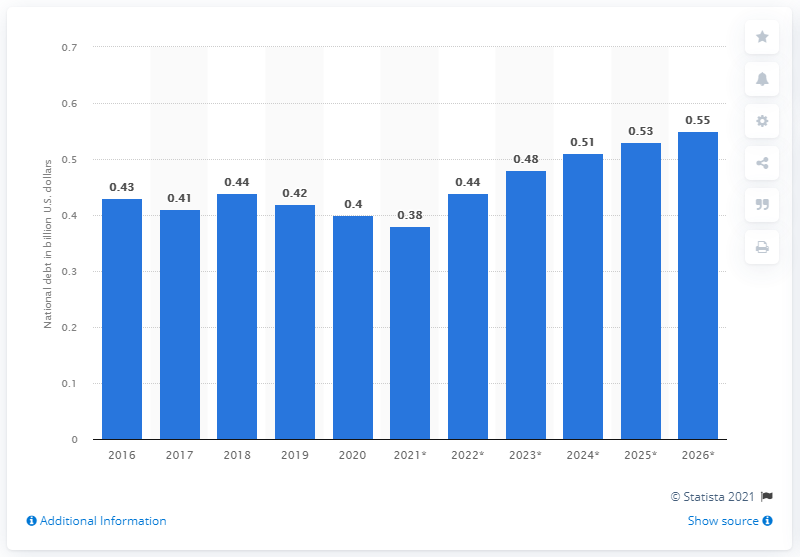Indicate a few pertinent items in this graphic. The national debt of Samoa is expected to end in 2020. According to available data, the national debt of Samoa in dollars in 2020 was approximately 0.4 billion dollars. 